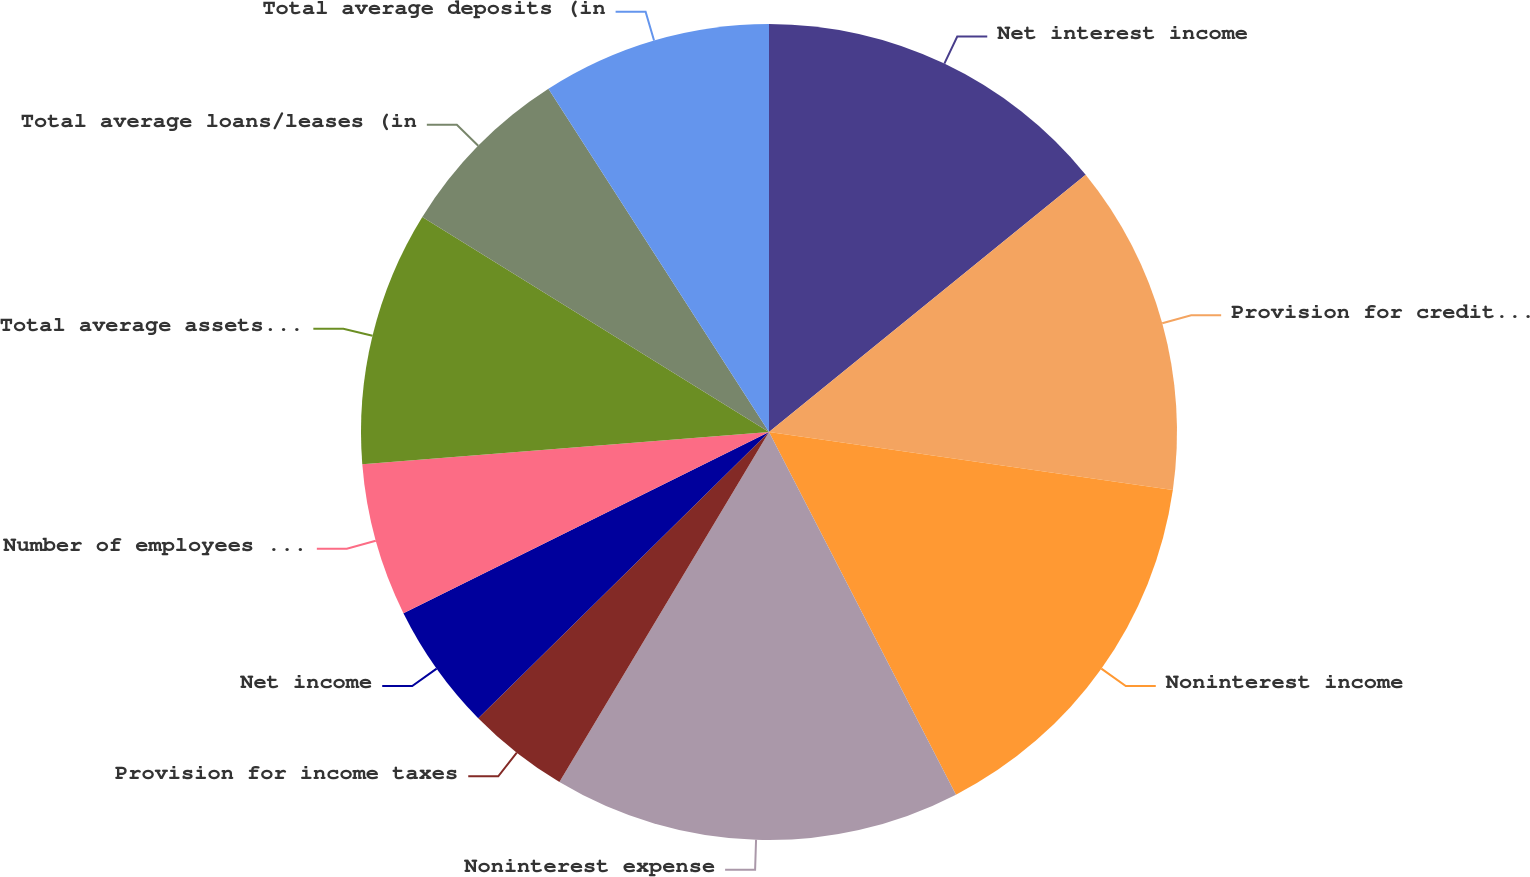Convert chart. <chart><loc_0><loc_0><loc_500><loc_500><pie_chart><fcel>Net interest income<fcel>Provision for credit losses<fcel>Noninterest income<fcel>Noninterest expense<fcel>Provision for income taxes<fcel>Net income<fcel>Number of employees (full-time<fcel>Total average assets (in<fcel>Total average loans/leases (in<fcel>Total average deposits (in<nl><fcel>14.14%<fcel>13.13%<fcel>15.15%<fcel>16.16%<fcel>4.04%<fcel>5.05%<fcel>6.06%<fcel>10.1%<fcel>7.07%<fcel>9.09%<nl></chart> 